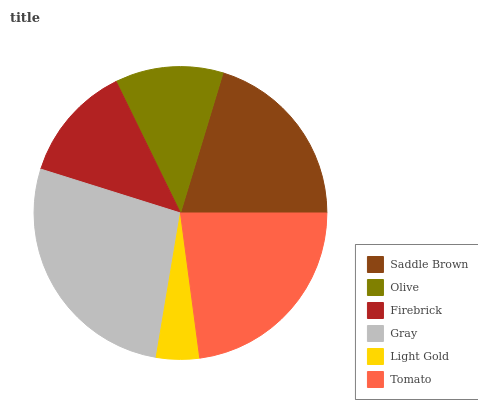Is Light Gold the minimum?
Answer yes or no. Yes. Is Gray the maximum?
Answer yes or no. Yes. Is Olive the minimum?
Answer yes or no. No. Is Olive the maximum?
Answer yes or no. No. Is Saddle Brown greater than Olive?
Answer yes or no. Yes. Is Olive less than Saddle Brown?
Answer yes or no. Yes. Is Olive greater than Saddle Brown?
Answer yes or no. No. Is Saddle Brown less than Olive?
Answer yes or no. No. Is Saddle Brown the high median?
Answer yes or no. Yes. Is Firebrick the low median?
Answer yes or no. Yes. Is Light Gold the high median?
Answer yes or no. No. Is Saddle Brown the low median?
Answer yes or no. No. 